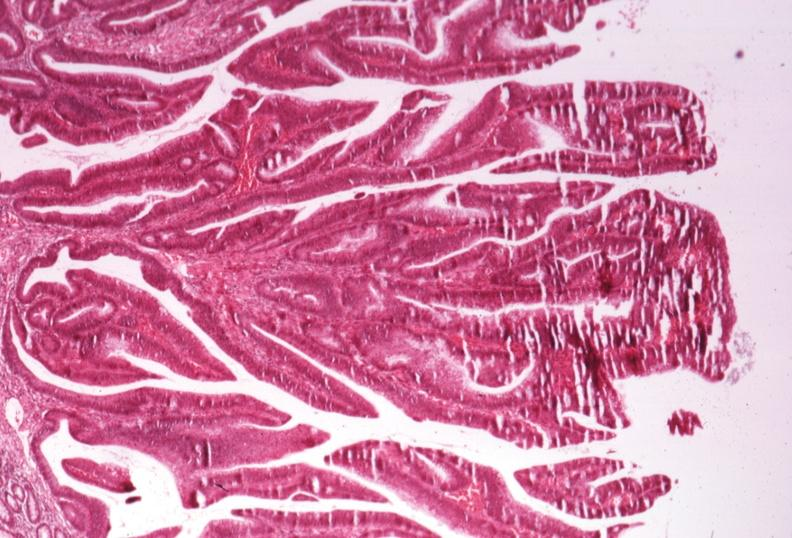s gangrene present?
Answer the question using a single word or phrase. No 